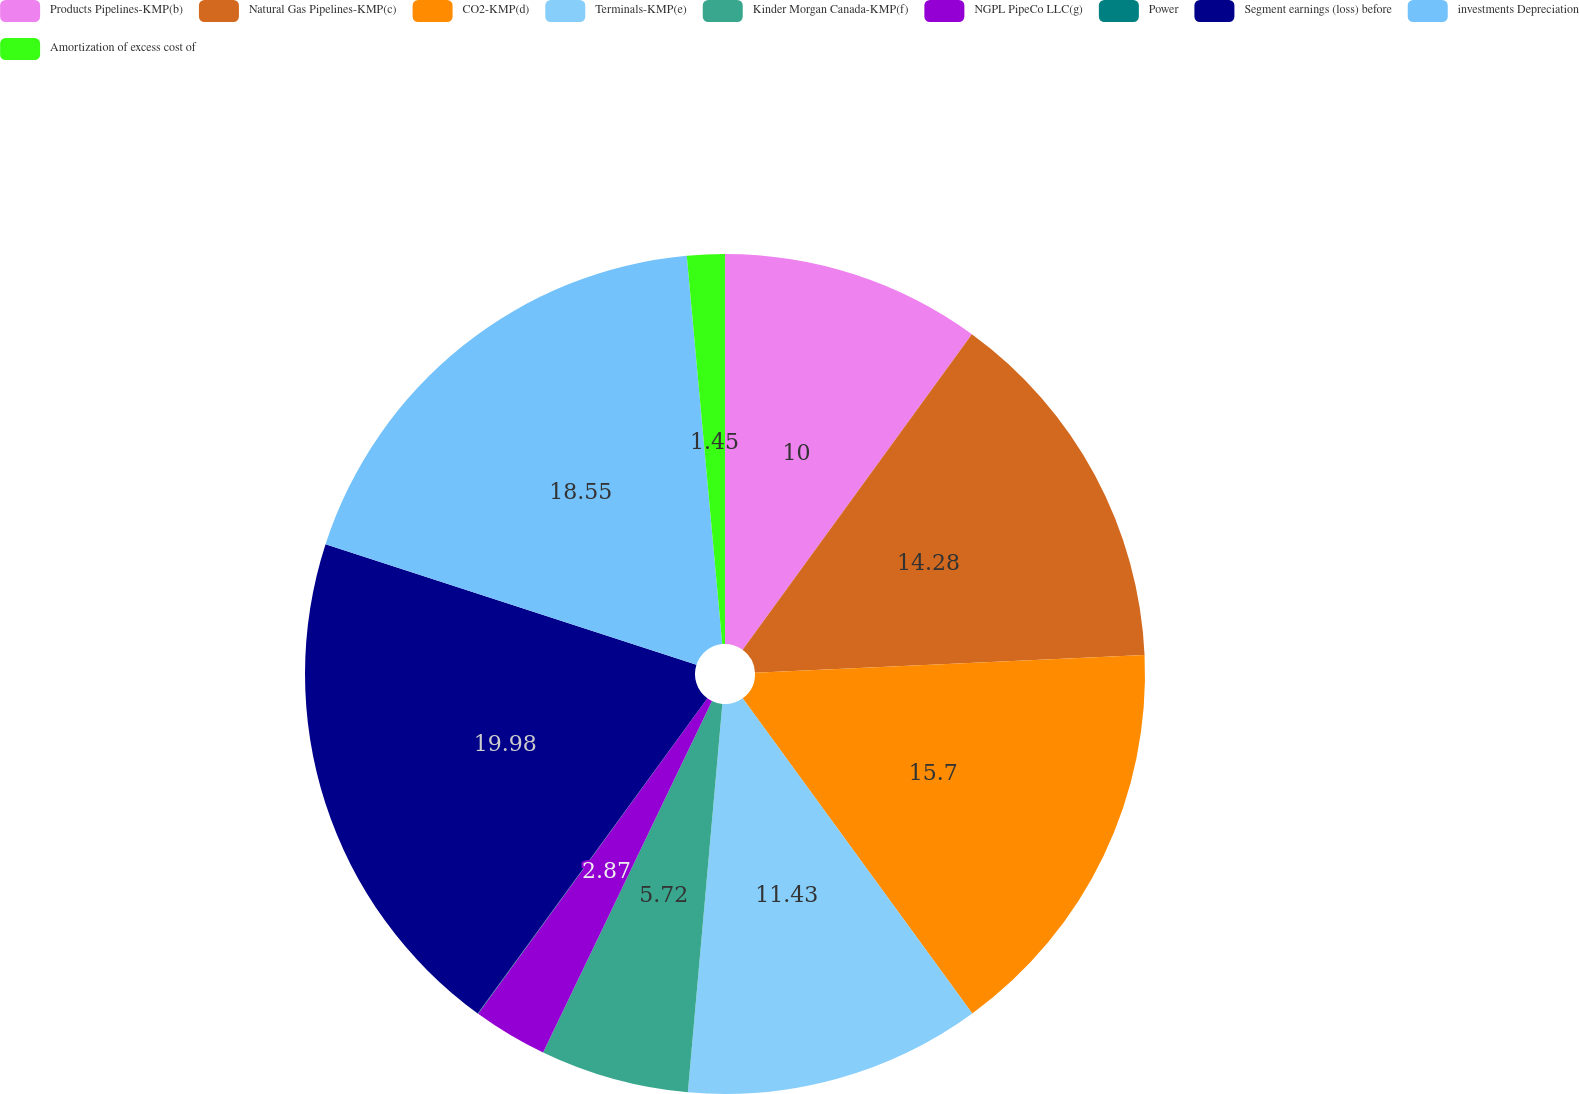<chart> <loc_0><loc_0><loc_500><loc_500><pie_chart><fcel>Products Pipelines-KMP(b)<fcel>Natural Gas Pipelines-KMP(c)<fcel>CO2-KMP(d)<fcel>Terminals-KMP(e)<fcel>Kinder Morgan Canada-KMP(f)<fcel>NGPL PipeCo LLC(g)<fcel>Power<fcel>Segment earnings (loss) before<fcel>investments Depreciation<fcel>Amortization of excess cost of<nl><fcel>10.0%<fcel>14.28%<fcel>15.7%<fcel>11.43%<fcel>5.72%<fcel>2.87%<fcel>0.02%<fcel>19.98%<fcel>18.55%<fcel>1.45%<nl></chart> 